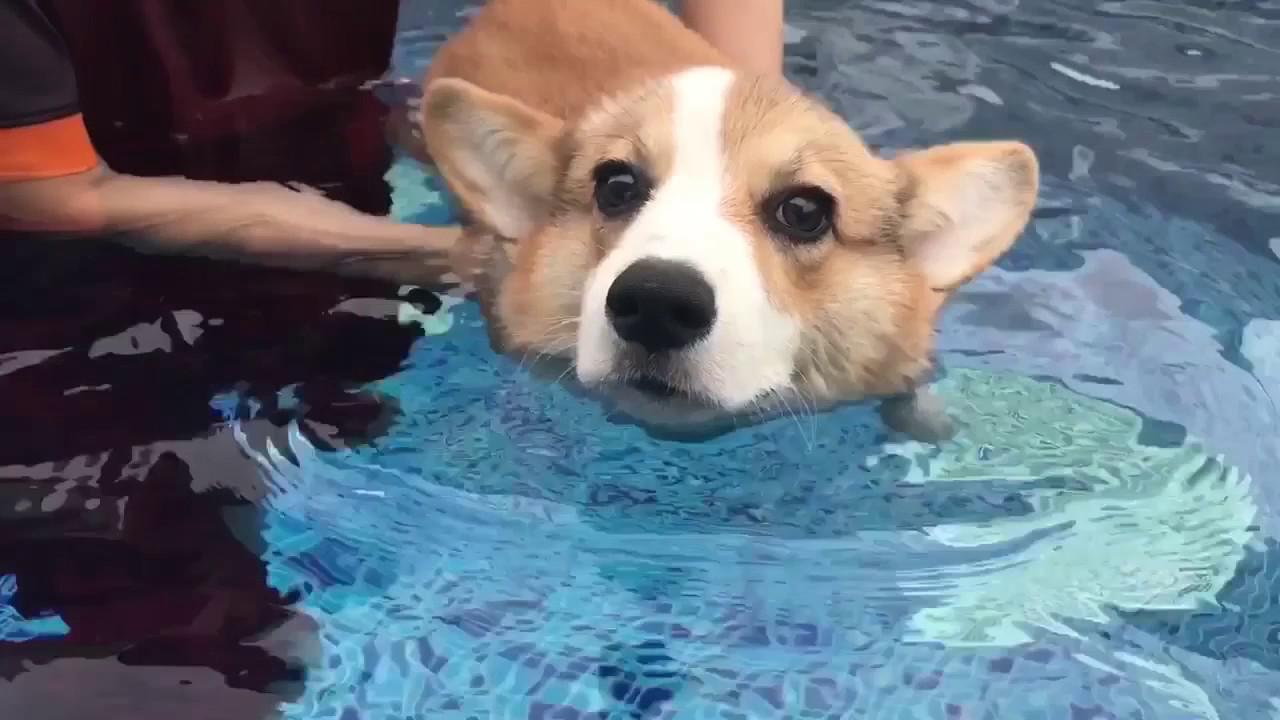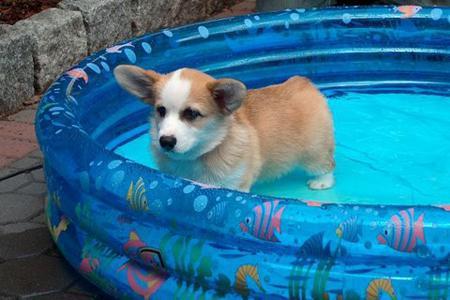The first image is the image on the left, the second image is the image on the right. Evaluate the accuracy of this statement regarding the images: "No less than one dog is in mid air jumping over a hurdle". Is it true? Answer yes or no. No. The first image is the image on the left, the second image is the image on the right. For the images displayed, is the sentence "The dog in the right image is inside of a small inflatable swimming pool." factually correct? Answer yes or no. Yes. 